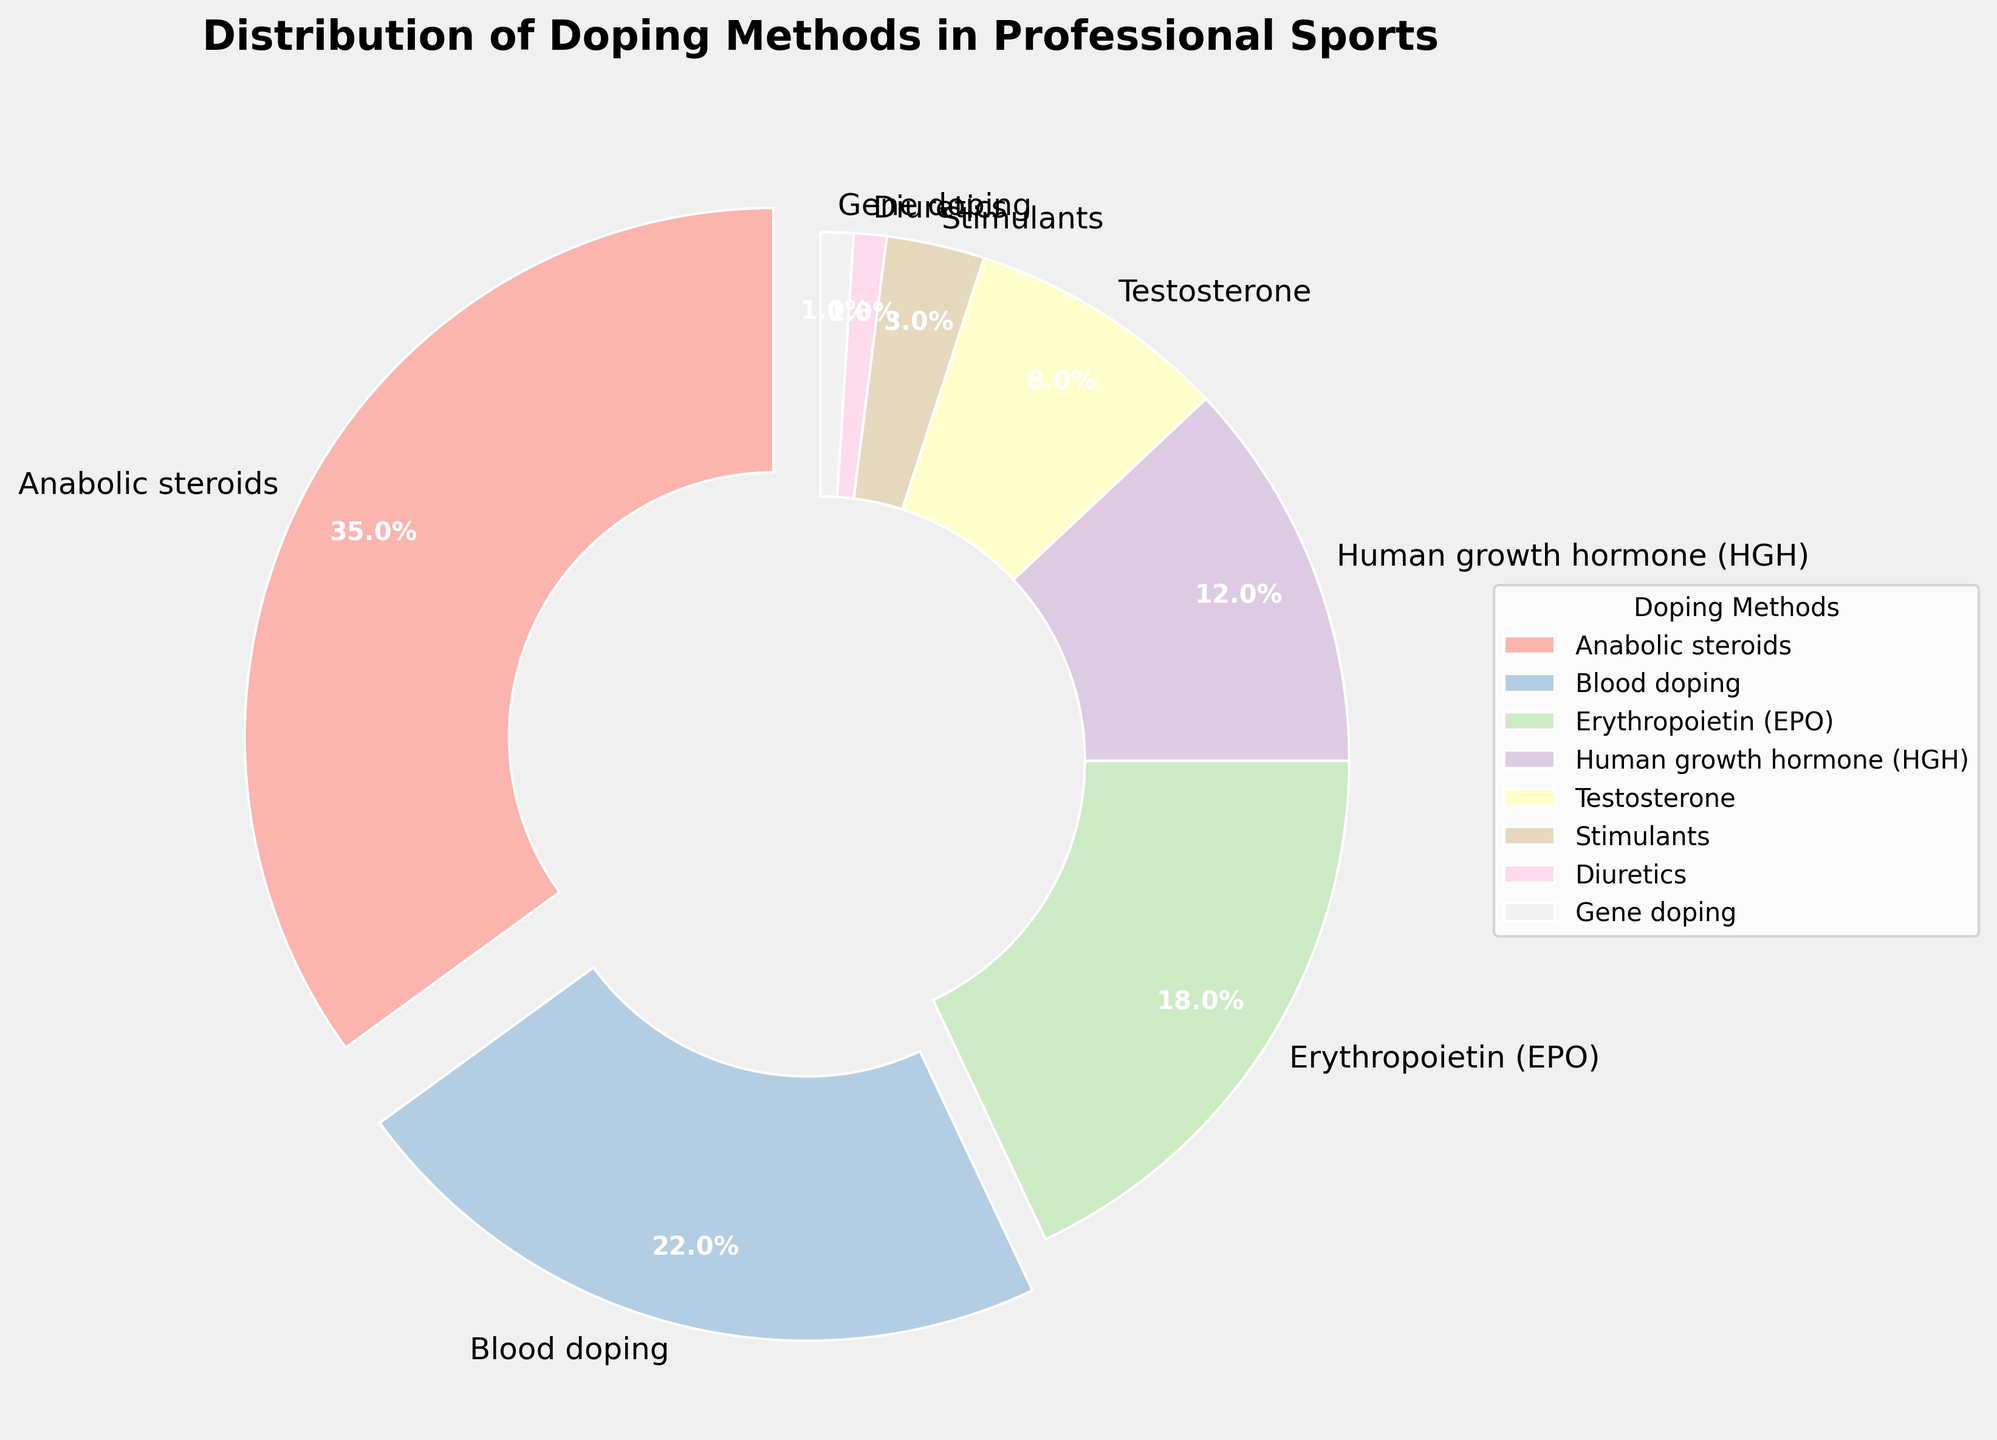what is the most common doping method used? The method with the highest percentage on the pie chart represents the most common doping method. By looking at the chart, anabolic steroids have a percentage of 35%, which is the highest among all the methods.
Answer: anabolic steroids Which doping method is used less, stimulants or diuretics? By comparing the two slices that represent stimulants and diuretics on the pie chart, stimulants have a percentage of 3%, while diuretics have a percentage of 1%. Therefore, diuretics are used less.
Answer: diuretics What is the combined percentage of blood doping and erythropoietin (EPO)? To find the combined percentage, sum the individual percentages of blood doping and erythropoietin (EPO). Blood doping is 22% and EPO is 18%, so the combined percentage is 22% + 18% = 40%.
Answer: 40% How much more common is anabolic steroids usage compared to testosterone usage? This involves finding the difference between the percentage of anabolic steroids (35%) and testosterone (8%). The difference is 35% - 8% = 27%.
Answer: 27% Which doping method has the smallest percentage? By looking at the pie chart, the smallest slices correspond to diuretics and gene doping, both with a percentage of 1%.
Answer: diuretics and gene doping What percentage of doping methods consist of human growth hormone (HGH) and testosterone combined? Adding the percentages of HGH (12%) and testosterone (8%) gives a combined percentage of 12% + 8% = 20%.
Answer: 20% If you were to describe the section representing blood doping based on its visual attributes, how would you describe it? The section for blood doping is the second largest section on the pie chart, has a slightly exploded effect, and is colored with a pastel shade.
Answer: second largest, slightly exploded, pastel shade How does the use of erythropoietin (EPO) compare to human growth hormone (HGH)? EPO usage is represented by a larger section compared to HGH. EPO has a percentage of 18%, while HGH has a percentage of 12%, making EPO more common.
Answer: EPO is more common than HGH Which methods have a combined percentage greater than 50%? To find this, identify methods whose combined percentages exceed 50%. Anabolic steroids (35%) and blood doping (22%) together sum to 57%, which is greater than 50%.
Answer: anabolic steroids and blood doping 